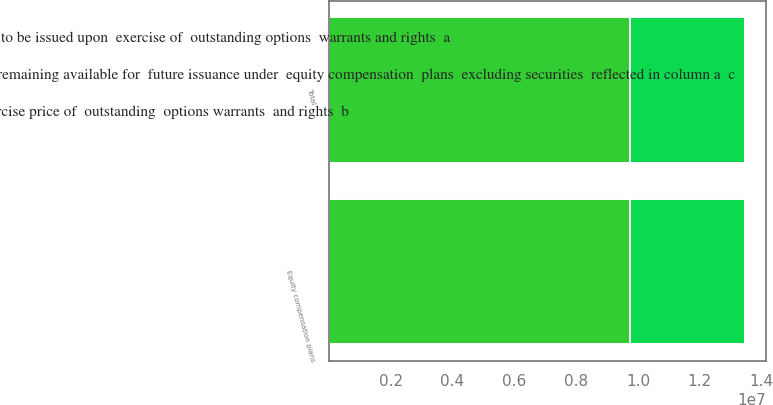Convert chart. <chart><loc_0><loc_0><loc_500><loc_500><stacked_bar_chart><ecel><fcel>Equity compensation plans<fcel>Total<nl><fcel>Number of securities  remaining available for  future issuance under  equity compensation  plans  excluding securities  reflected in column a  c<fcel>9.74874e+06<fcel>9.74874e+06<nl><fcel>Number of  securities  to be issued upon  exercise of  outstanding options  warrants and rights  a<fcel>17.18<fcel>17.18<nl><fcel>Weightedaverage  exercise price of  outstanding  options warrants  and rights  b<fcel>3.7174e+06<fcel>3.7174e+06<nl></chart> 